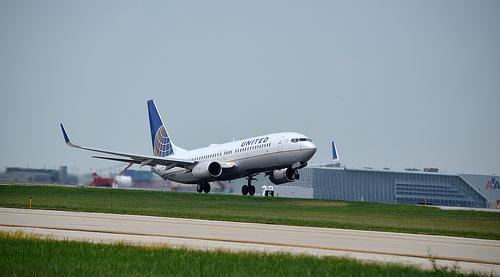How many planes are visible?
Give a very brief answer. 1. 